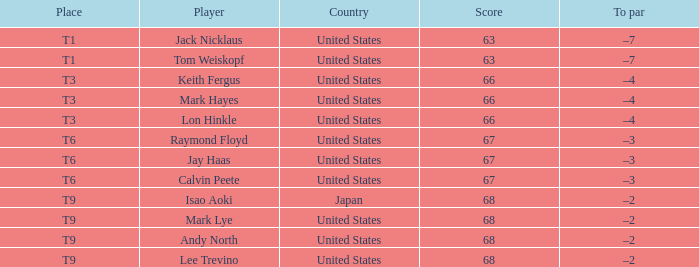What is To Par, when Place is "T9", and when Player is "Lee Trevino"? –2. 